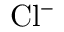<formula> <loc_0><loc_0><loc_500><loc_500>C l ^ { - }</formula> 